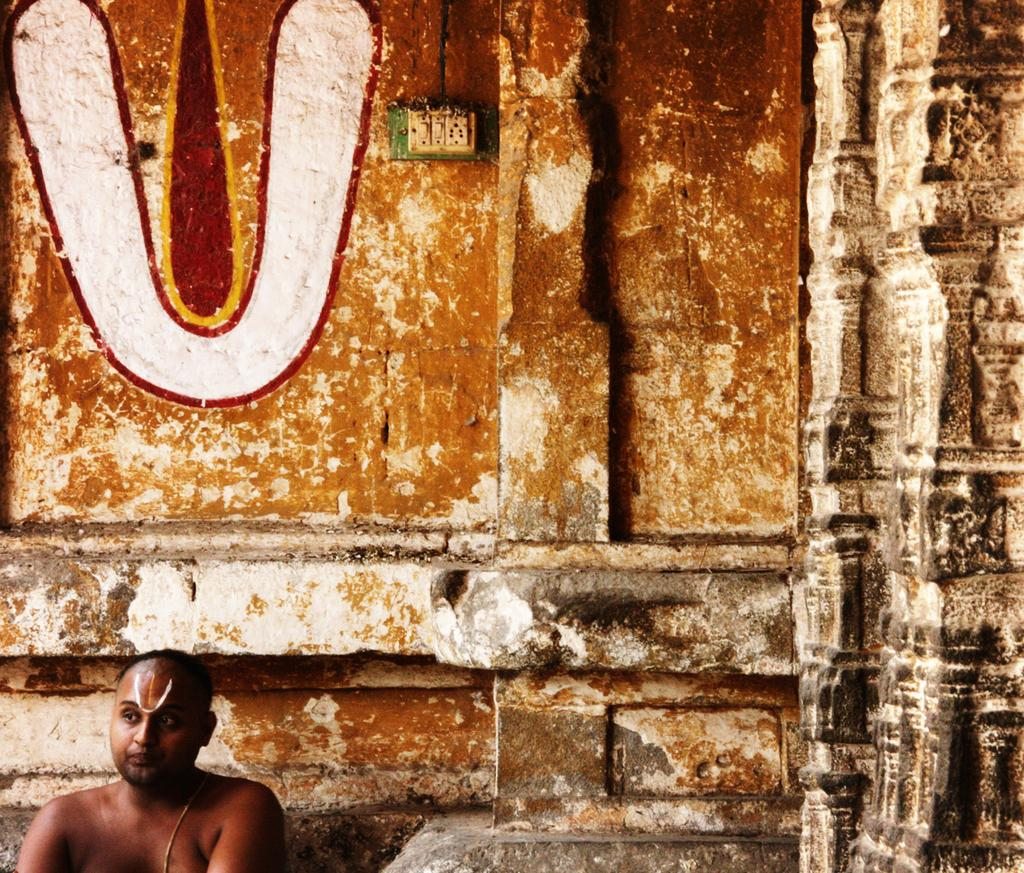What is located on the left side of the image? There is a man on the left side of the image. What can be seen on the wall in the image? There is a painting on the wall in the image. What device is present in the image? There is a switch board in the image. What committee is responsible for the painting in the image? There is no mention of a committee in the image, and the painting's origin is not specified. How does the man in the image drop the switch board? There is no indication that the man is dropping the switch board in the image; he is simply standing on the left side. 